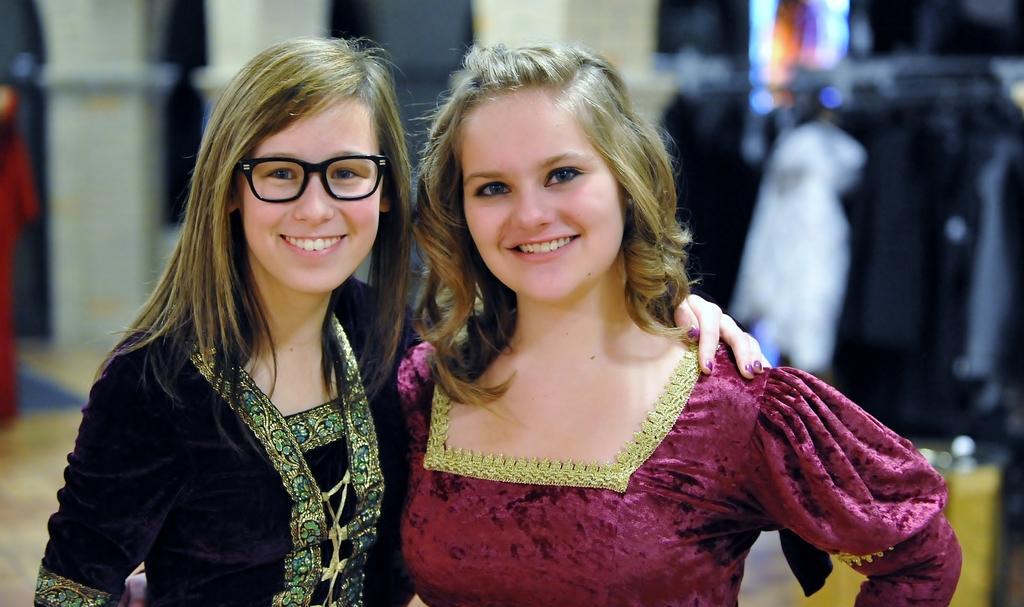Describe this image in one or two sentences. In this image we can see two girls are smiling. One girl is wearing pink color dress and other girl is wearing black color dress with specks. 